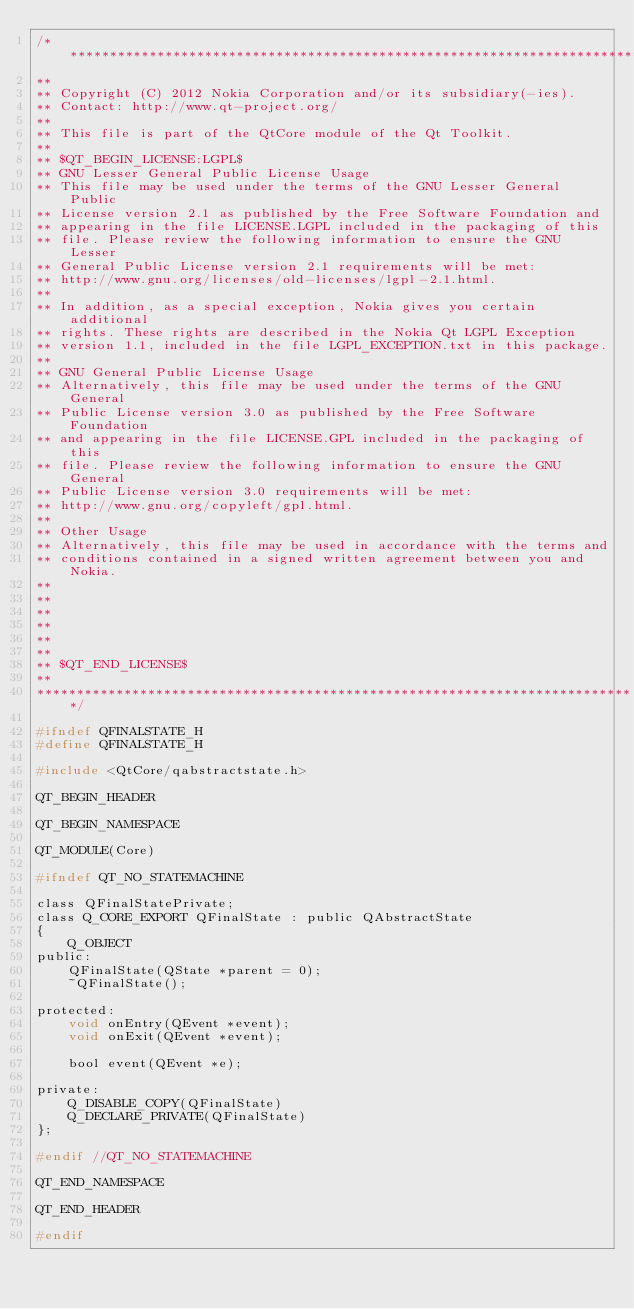Convert code to text. <code><loc_0><loc_0><loc_500><loc_500><_C_>/****************************************************************************
**
** Copyright (C) 2012 Nokia Corporation and/or its subsidiary(-ies).
** Contact: http://www.qt-project.org/
**
** This file is part of the QtCore module of the Qt Toolkit.
**
** $QT_BEGIN_LICENSE:LGPL$
** GNU Lesser General Public License Usage
** This file may be used under the terms of the GNU Lesser General Public
** License version 2.1 as published by the Free Software Foundation and
** appearing in the file LICENSE.LGPL included in the packaging of this
** file. Please review the following information to ensure the GNU Lesser
** General Public License version 2.1 requirements will be met:
** http://www.gnu.org/licenses/old-licenses/lgpl-2.1.html.
**
** In addition, as a special exception, Nokia gives you certain additional
** rights. These rights are described in the Nokia Qt LGPL Exception
** version 1.1, included in the file LGPL_EXCEPTION.txt in this package.
**
** GNU General Public License Usage
** Alternatively, this file may be used under the terms of the GNU General
** Public License version 3.0 as published by the Free Software Foundation
** and appearing in the file LICENSE.GPL included in the packaging of this
** file. Please review the following information to ensure the GNU General
** Public License version 3.0 requirements will be met:
** http://www.gnu.org/copyleft/gpl.html.
**
** Other Usage
** Alternatively, this file may be used in accordance with the terms and
** conditions contained in a signed written agreement between you and Nokia.
**
**
**
**
**
**
** $QT_END_LICENSE$
**
****************************************************************************/

#ifndef QFINALSTATE_H
#define QFINALSTATE_H

#include <QtCore/qabstractstate.h>

QT_BEGIN_HEADER

QT_BEGIN_NAMESPACE

QT_MODULE(Core)

#ifndef QT_NO_STATEMACHINE

class QFinalStatePrivate;
class Q_CORE_EXPORT QFinalState : public QAbstractState
{
    Q_OBJECT
public:
    QFinalState(QState *parent = 0);
    ~QFinalState();

protected:
    void onEntry(QEvent *event);
    void onExit(QEvent *event);

    bool event(QEvent *e);

private:
    Q_DISABLE_COPY(QFinalState)
    Q_DECLARE_PRIVATE(QFinalState)
};

#endif //QT_NO_STATEMACHINE

QT_END_NAMESPACE

QT_END_HEADER

#endif
</code> 